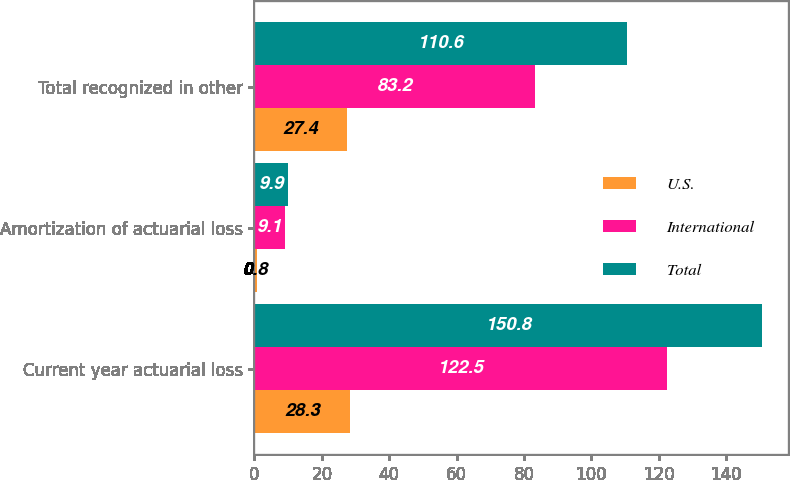Convert chart to OTSL. <chart><loc_0><loc_0><loc_500><loc_500><stacked_bar_chart><ecel><fcel>Current year actuarial loss<fcel>Amortization of actuarial loss<fcel>Total recognized in other<nl><fcel>U.S.<fcel>28.3<fcel>0.8<fcel>27.4<nl><fcel>International<fcel>122.5<fcel>9.1<fcel>83.2<nl><fcel>Total<fcel>150.8<fcel>9.9<fcel>110.6<nl></chart> 